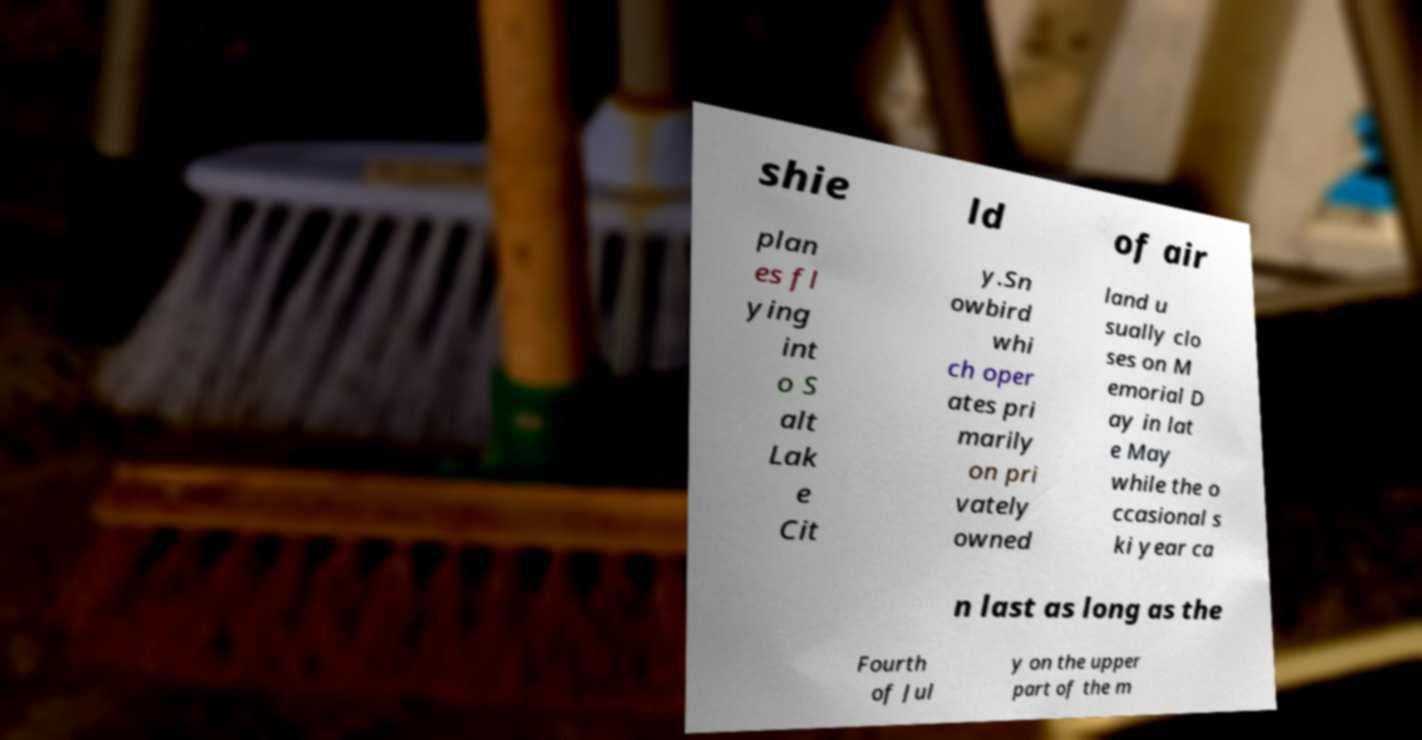Can you read and provide the text displayed in the image?This photo seems to have some interesting text. Can you extract and type it out for me? shie ld of air plan es fl ying int o S alt Lak e Cit y.Sn owbird whi ch oper ates pri marily on pri vately owned land u sually clo ses on M emorial D ay in lat e May while the o ccasional s ki year ca n last as long as the Fourth of Jul y on the upper part of the m 